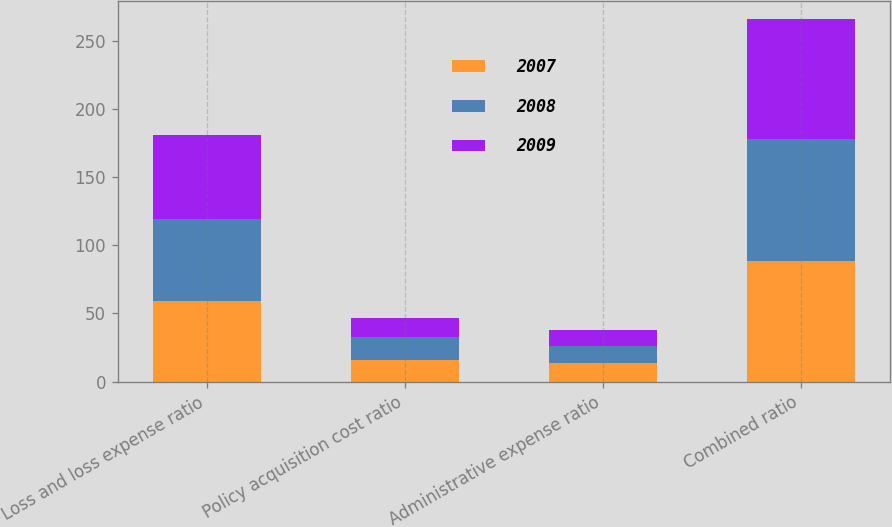<chart> <loc_0><loc_0><loc_500><loc_500><stacked_bar_chart><ecel><fcel>Loss and loss expense ratio<fcel>Policy acquisition cost ratio<fcel>Administrative expense ratio<fcel>Combined ratio<nl><fcel>2007<fcel>58.8<fcel>16.2<fcel>13.3<fcel>88.3<nl><fcel>2008<fcel>60.6<fcel>16.2<fcel>12.8<fcel>89.6<nl><fcel>2009<fcel>61.6<fcel>14.5<fcel>11.8<fcel>87.9<nl></chart> 